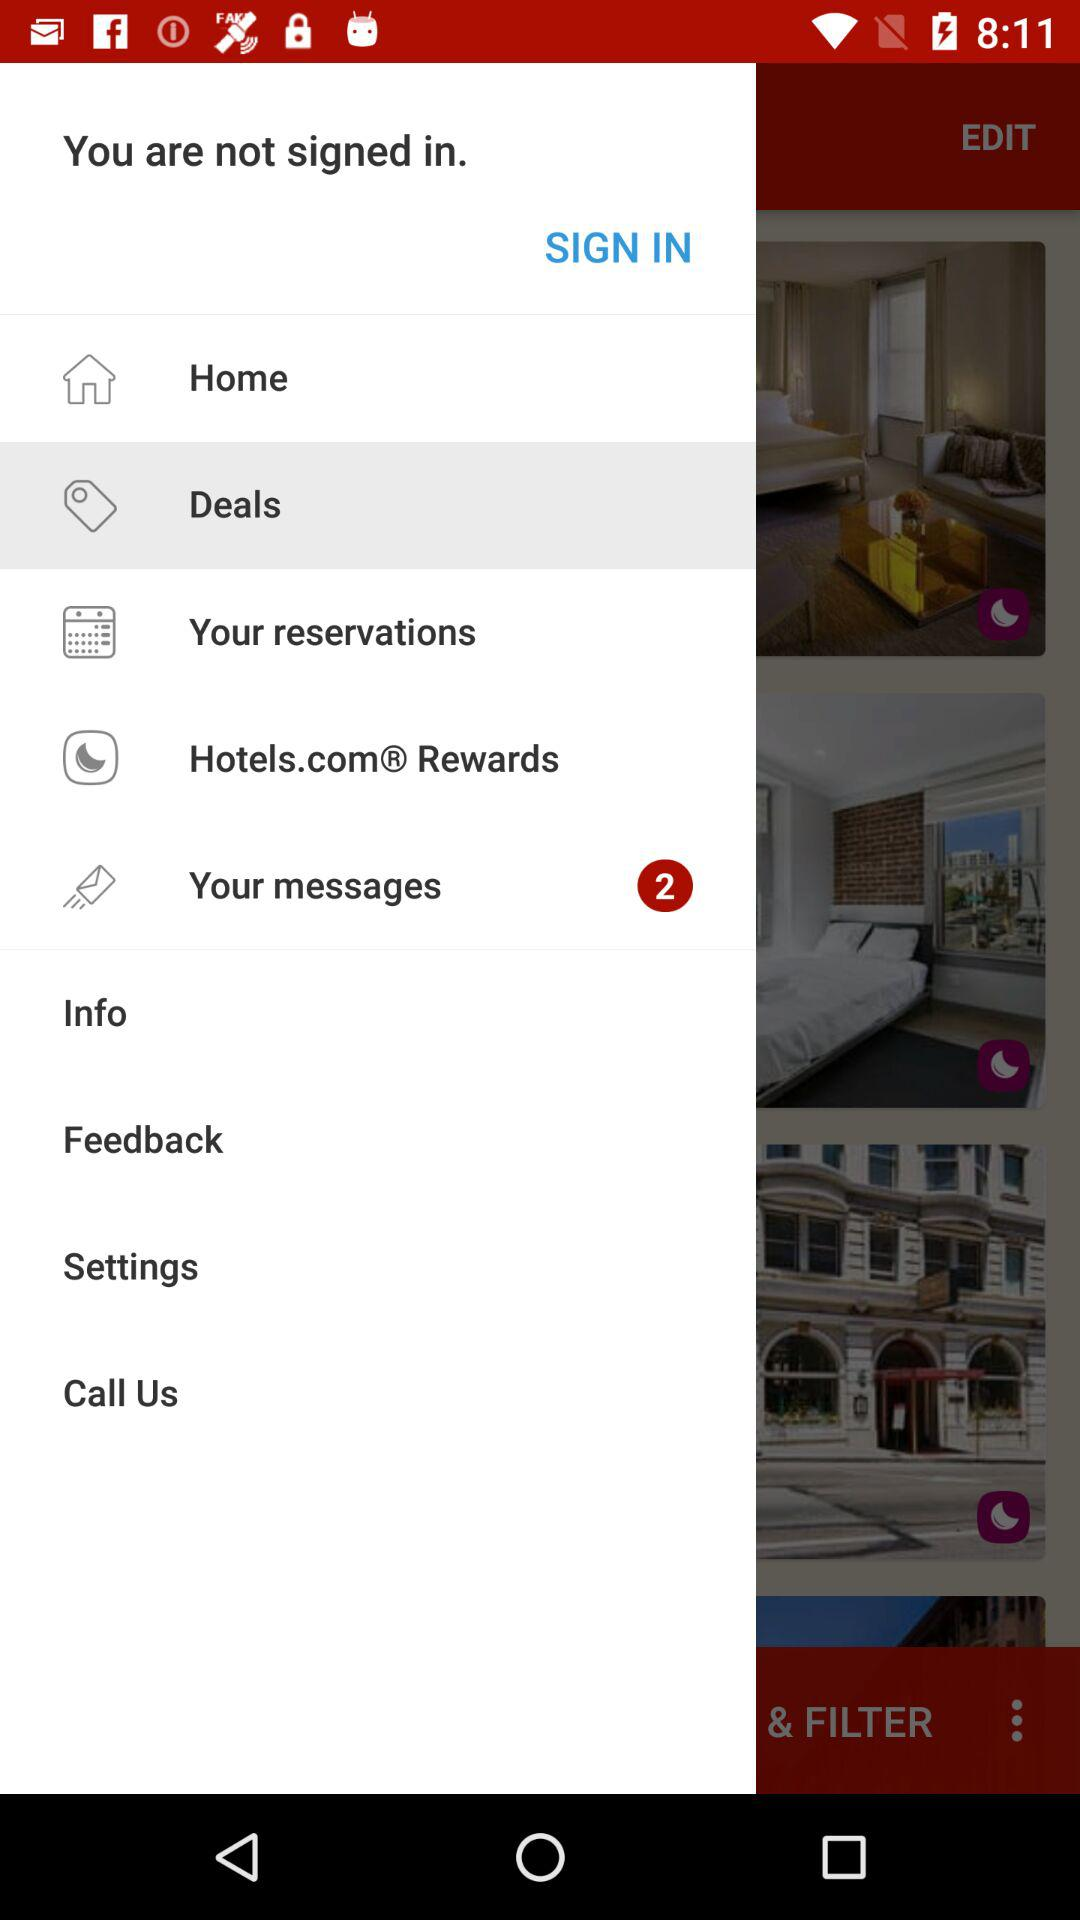Which is the selected item in the menu? The selected item in the menu is "Deals". 